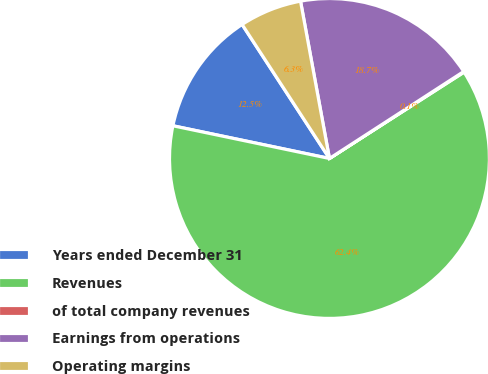Convert chart to OTSL. <chart><loc_0><loc_0><loc_500><loc_500><pie_chart><fcel>Years ended December 31<fcel>Revenues<fcel>of total company revenues<fcel>Earnings from operations<fcel>Operating margins<nl><fcel>12.53%<fcel>62.36%<fcel>0.07%<fcel>18.75%<fcel>6.3%<nl></chart> 